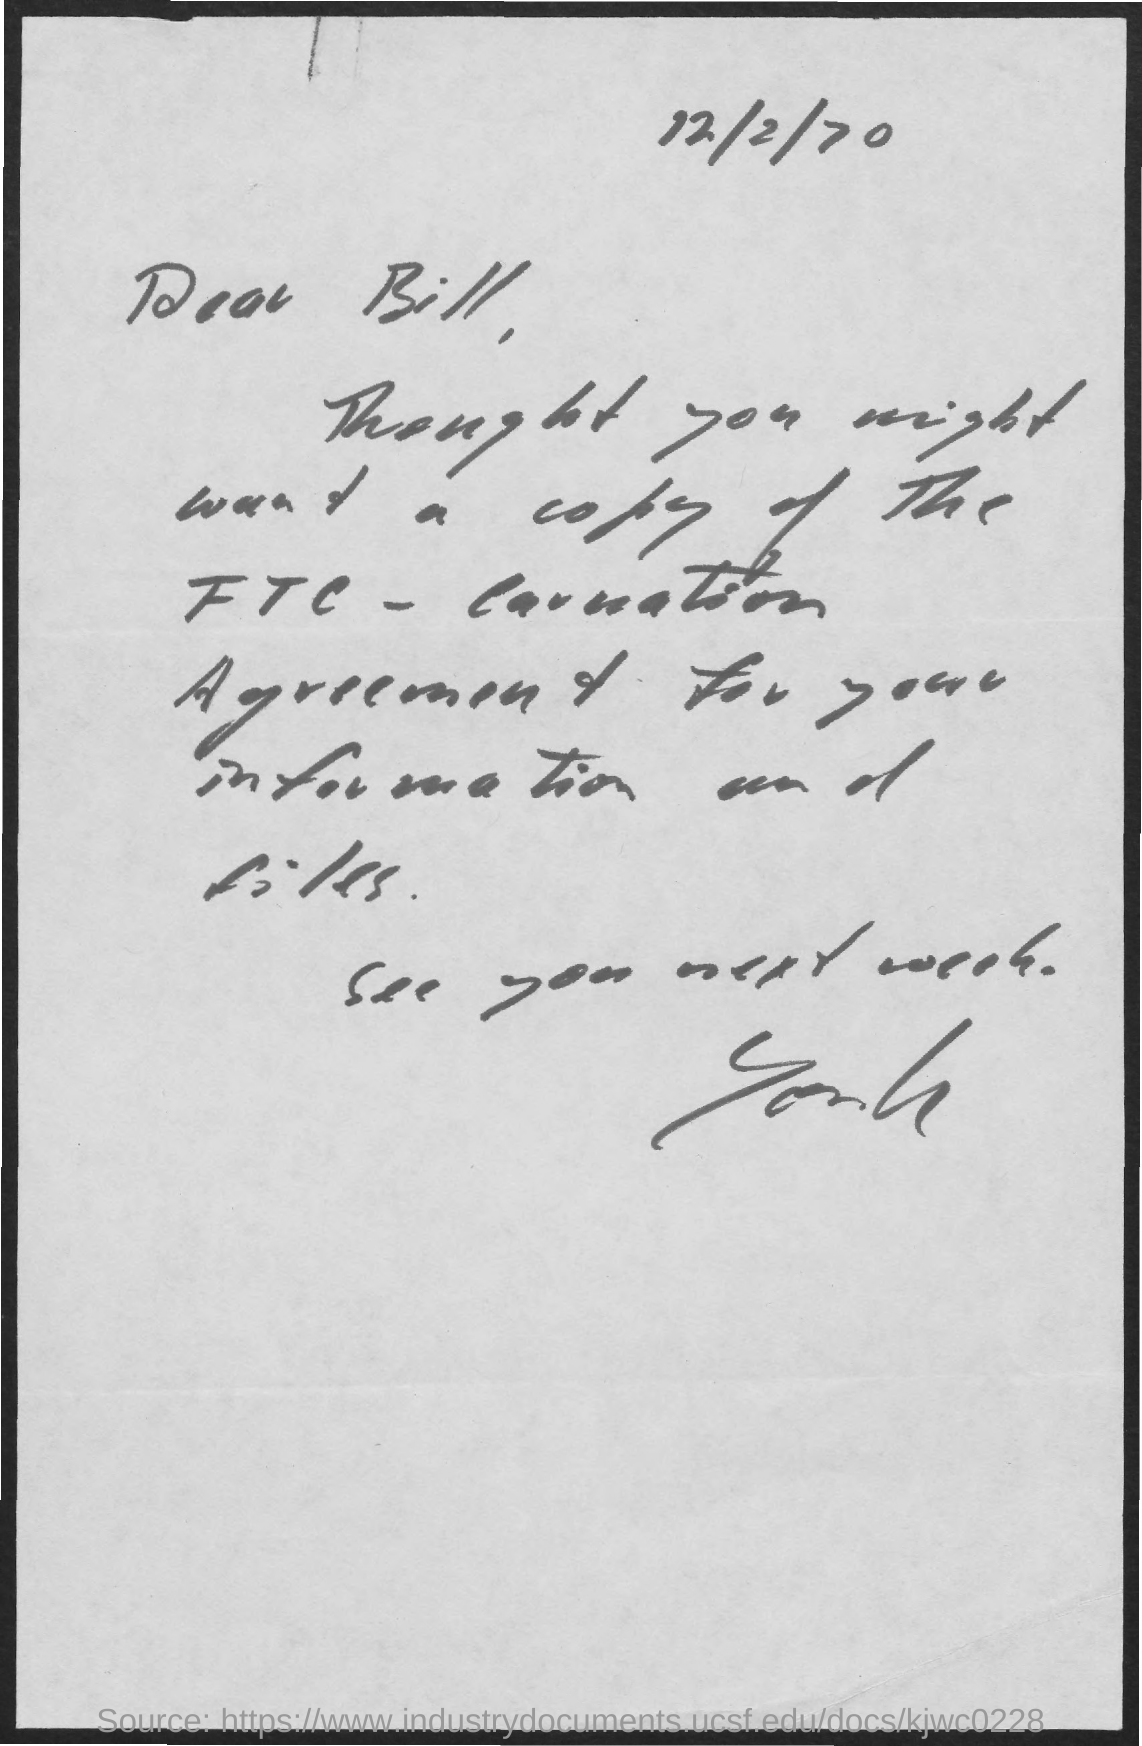What is the date on the document?
Provide a short and direct response. 12/2/70. To Whom is this letter addressed to?
Keep it short and to the point. Bill. 